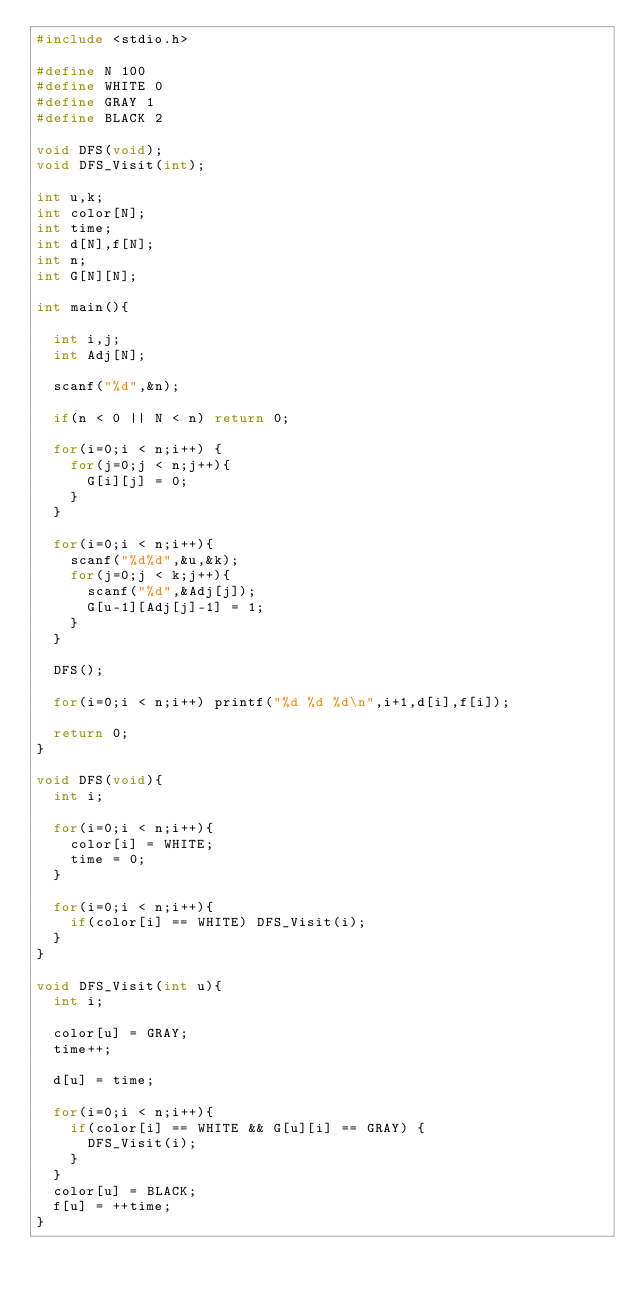Convert code to text. <code><loc_0><loc_0><loc_500><loc_500><_C_>#include <stdio.h>

#define N 100
#define WHITE 0
#define GRAY 1
#define BLACK 2

void DFS(void);
void DFS_Visit(int);

int u,k;
int color[N];
int time;
int d[N],f[N];
int n;
int G[N][N];

int main(){
  
  int i,j;
  int Adj[N];  

  scanf("%d",&n);

  if(n < 0 || N < n) return 0;
  
  for(i=0;i < n;i++) {
    for(j=0;j < n;j++){
      G[i][j] = 0;
    }
  }

  for(i=0;i < n;i++){
    scanf("%d%d",&u,&k);
    for(j=0;j < k;j++){
      scanf("%d",&Adj[j]);
      G[u-1][Adj[j]-1] = 1;
    }
  }
  
  DFS();

  for(i=0;i < n;i++) printf("%d %d %d\n",i+1,d[i],f[i]);
  
  return 0;
}

void DFS(void){
  int i;
  
  for(i=0;i < n;i++){
    color[i] = WHITE;
    time = 0;
  }
  
  for(i=0;i < n;i++){
    if(color[i] == WHITE) DFS_Visit(i);
  }
}

void DFS_Visit(int u){
  int i;
  
  color[u] = GRAY;
  time++;

  d[u] = time;
  
  for(i=0;i < n;i++){
    if(color[i] == WHITE && G[u][i] == GRAY) {
      DFS_Visit(i);
    }
  }
  color[u] = BLACK;
  f[u] = ++time;
}</code> 